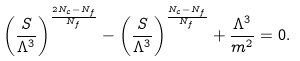<formula> <loc_0><loc_0><loc_500><loc_500>\left ( \frac { S } { \Lambda ^ { 3 } } \right ) ^ { \frac { 2 N _ { c } - N _ { f } } { N _ { f } } } - \left ( \frac { S } { \Lambda ^ { 3 } } \right ) ^ { \frac { N _ { c } - N _ { f } } { N _ { f } } } + \frac { \Lambda ^ { 3 } } { m ^ { 2 } } = 0 .</formula> 